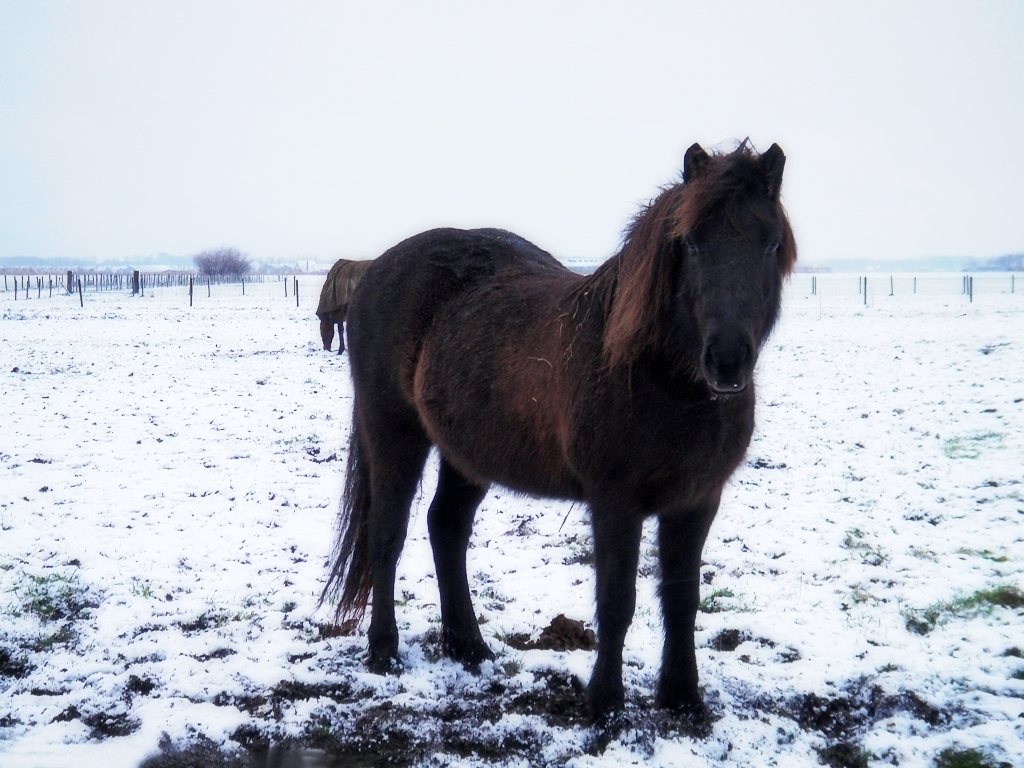What can we infer about the season and weather from this image? The presence of snow suggests that the season is likely winter. The sky is overcast, implying that it might have recently snowed or that snowfall could be imminent. The coat of the horse appears thick, which would be appropriate for colder temperatures and winter weather conditions. Does the horse's coat tell us anything else? Yes, the horse's thick and fluffy coat is a natural adaptation for winter – it helps to retain warmth by trapping air close to the body. In addition, the slightly unkempt look of the coat could indicate that the horse is a hardy breed, accustomed to living outdoors even in harsh weather conditions. 